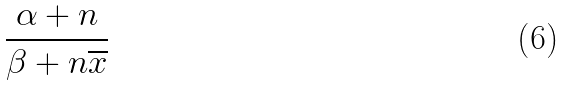<formula> <loc_0><loc_0><loc_500><loc_500>\frac { \alpha + n } { \beta + n \overline { x } }</formula> 